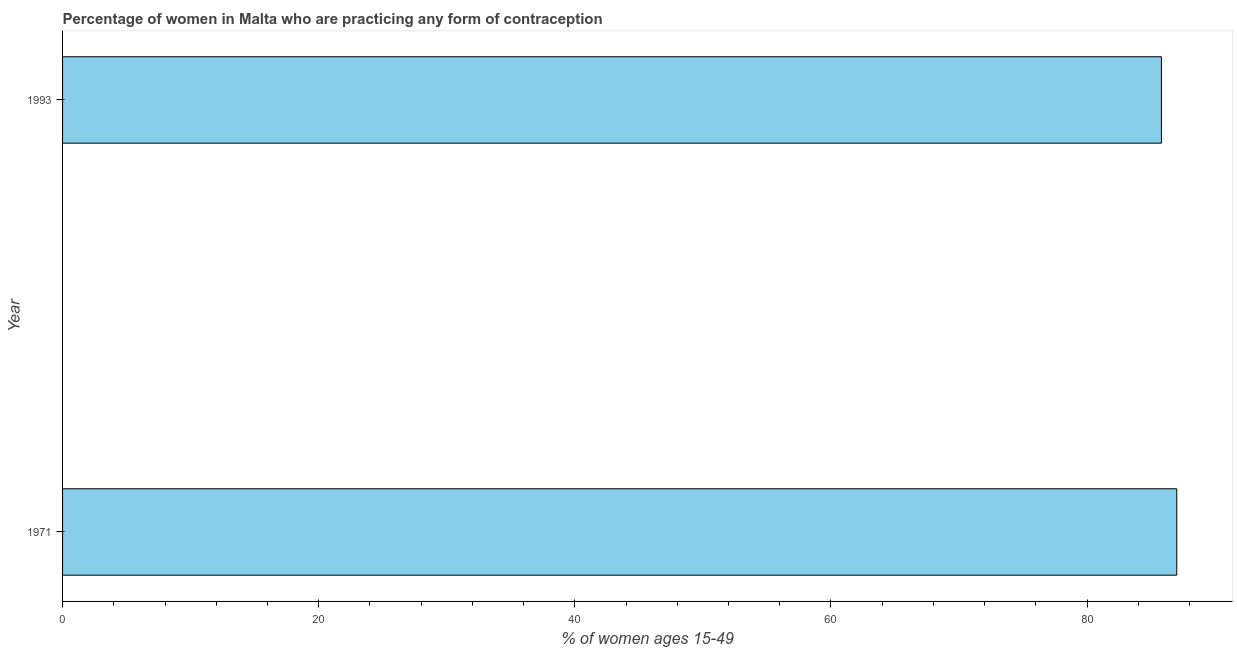Does the graph contain any zero values?
Provide a succinct answer. No. Does the graph contain grids?
Make the answer very short. No. What is the title of the graph?
Your response must be concise. Percentage of women in Malta who are practicing any form of contraception. What is the label or title of the X-axis?
Keep it short and to the point. % of women ages 15-49. What is the label or title of the Y-axis?
Provide a short and direct response. Year. What is the contraceptive prevalence in 1993?
Ensure brevity in your answer.  85.8. Across all years, what is the minimum contraceptive prevalence?
Offer a very short reply. 85.8. In which year was the contraceptive prevalence maximum?
Give a very brief answer. 1971. In which year was the contraceptive prevalence minimum?
Your answer should be very brief. 1993. What is the sum of the contraceptive prevalence?
Offer a very short reply. 172.8. What is the average contraceptive prevalence per year?
Give a very brief answer. 86.4. What is the median contraceptive prevalence?
Your response must be concise. 86.4. In how many years, is the contraceptive prevalence greater than the average contraceptive prevalence taken over all years?
Provide a short and direct response. 1. How many years are there in the graph?
Offer a very short reply. 2. What is the difference between two consecutive major ticks on the X-axis?
Give a very brief answer. 20. What is the % of women ages 15-49 in 1993?
Ensure brevity in your answer.  85.8. What is the difference between the % of women ages 15-49 in 1971 and 1993?
Offer a very short reply. 1.2. 